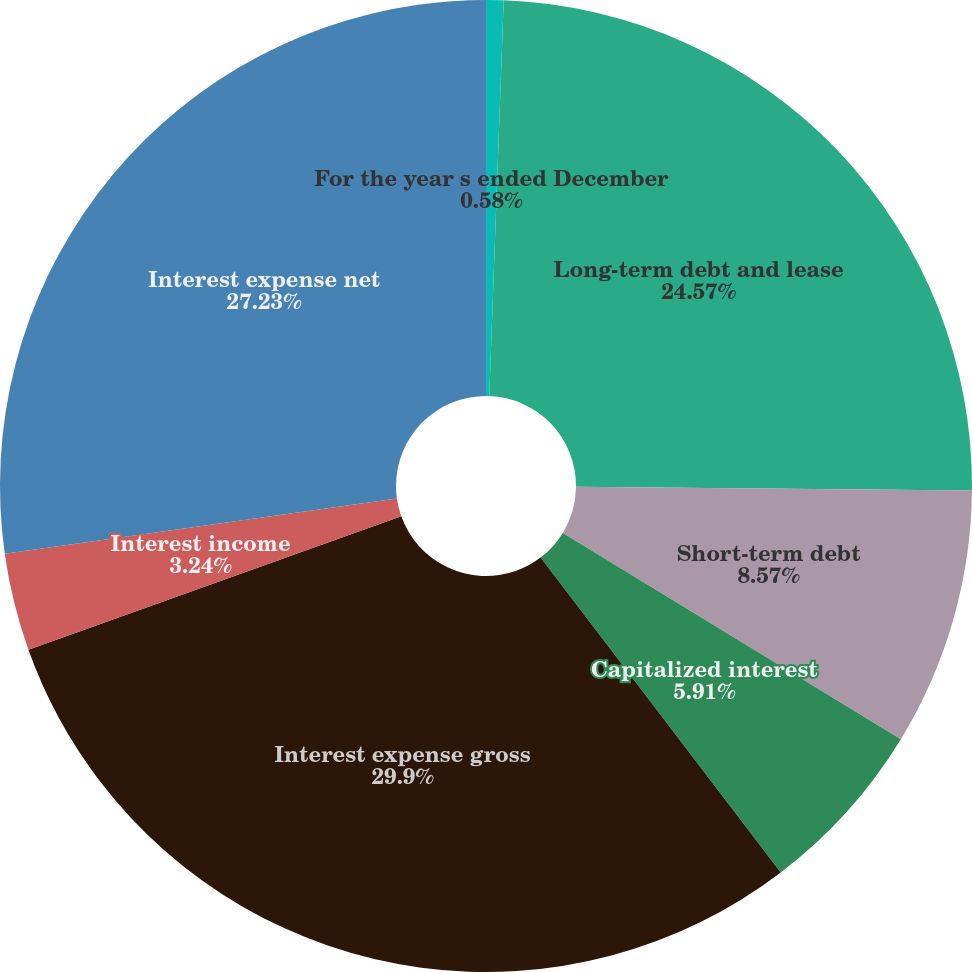<chart> <loc_0><loc_0><loc_500><loc_500><pie_chart><fcel>For the year s ended December<fcel>Long-term debt and lease<fcel>Short-term debt<fcel>Capitalized interest<fcel>Interest expense gross<fcel>Interest income<fcel>Interest expense net<nl><fcel>0.58%<fcel>24.57%<fcel>8.57%<fcel>5.91%<fcel>29.9%<fcel>3.24%<fcel>27.23%<nl></chart> 